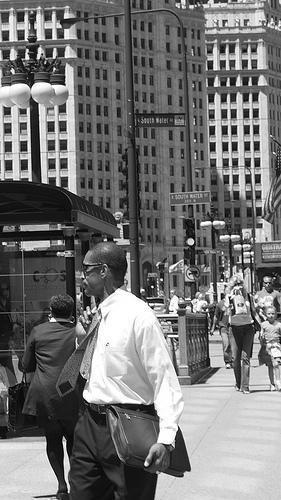How many street signs are in the image?
Give a very brief answer. 2. 